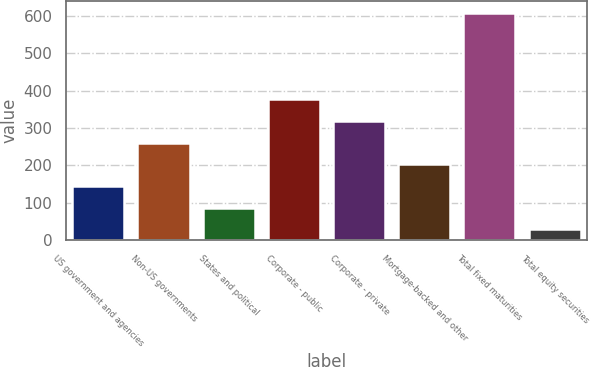<chart> <loc_0><loc_0><loc_500><loc_500><bar_chart><fcel>US government and agencies<fcel>Non-US governments<fcel>States and political<fcel>Corporate - public<fcel>Corporate - private<fcel>Mortgage-backed and other<fcel>Total fixed maturities<fcel>Total equity securities<nl><fcel>144.96<fcel>261.02<fcel>86.93<fcel>377.08<fcel>319.05<fcel>202.99<fcel>609.2<fcel>28.9<nl></chart> 